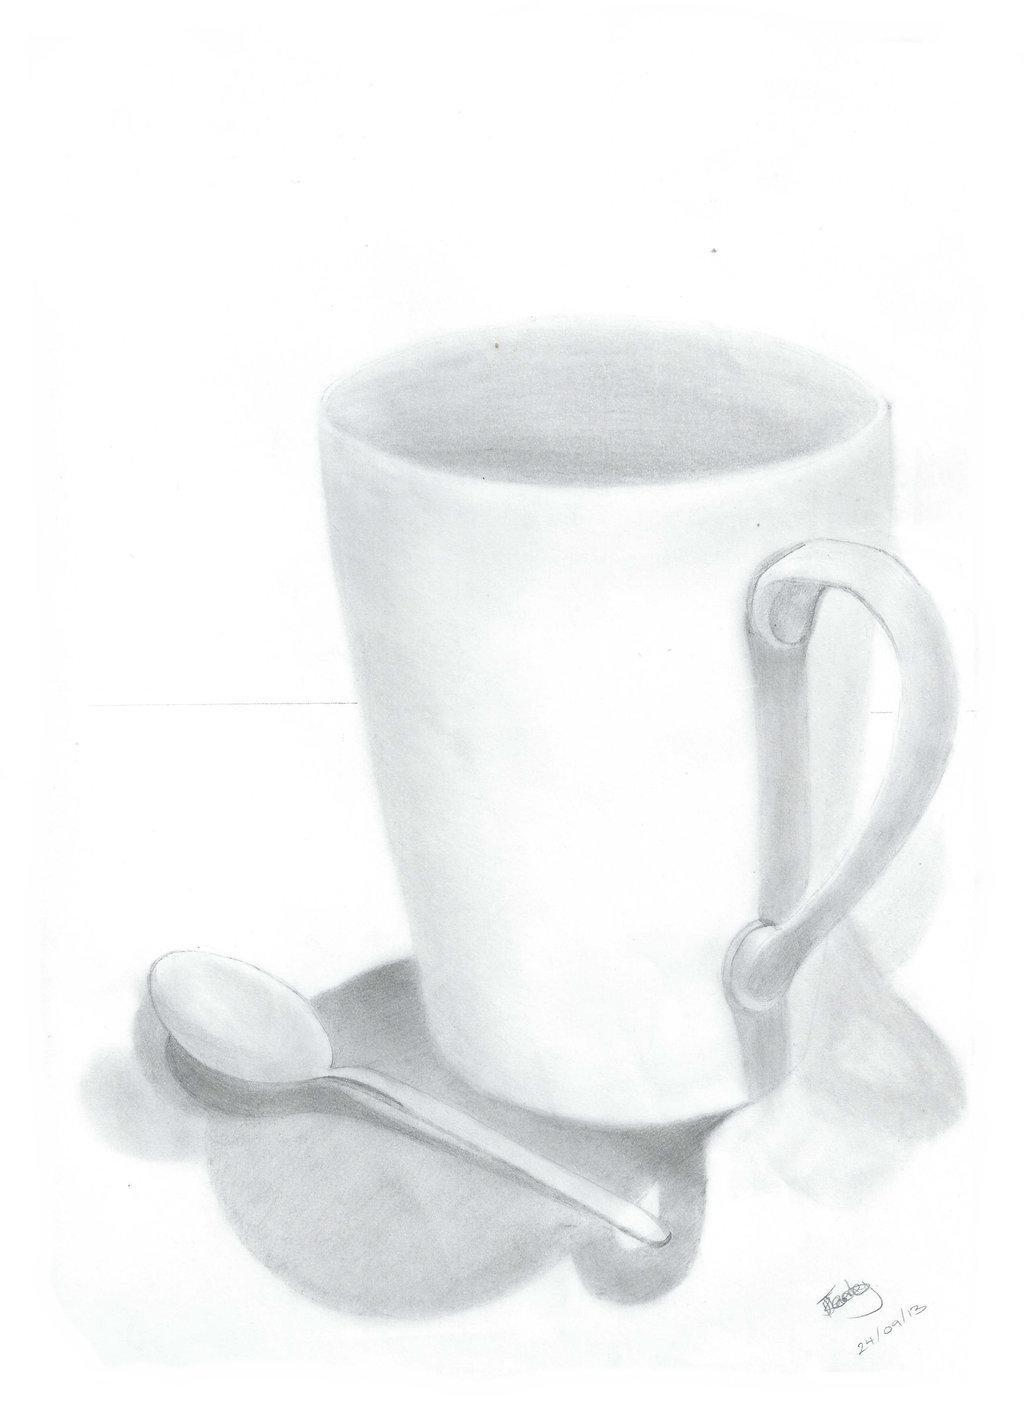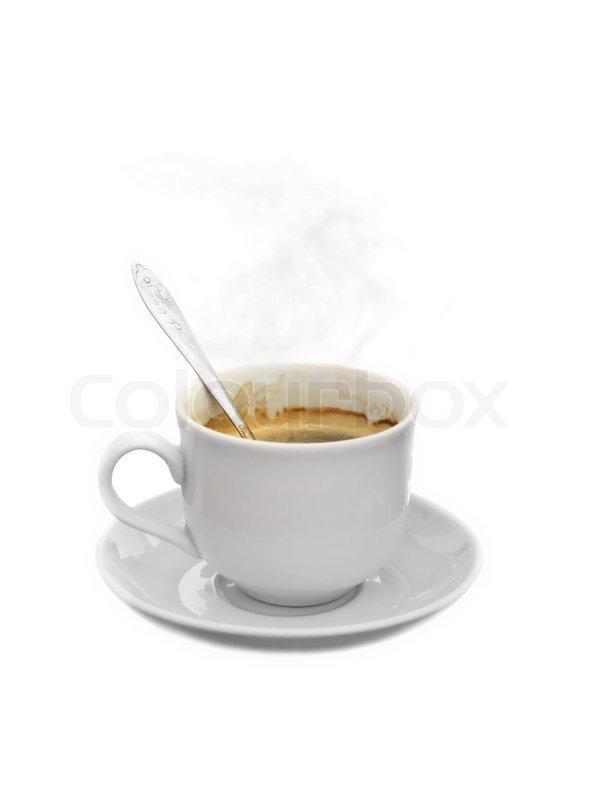The first image is the image on the left, the second image is the image on the right. Analyze the images presented: Is the assertion "In 1 of the images, an empty cup has a spoon in it." valid? Answer yes or no. No. The first image is the image on the left, the second image is the image on the right. Evaluate the accuracy of this statement regarding the images: "Steam is visible in one of the images.". Is it true? Answer yes or no. Yes. 